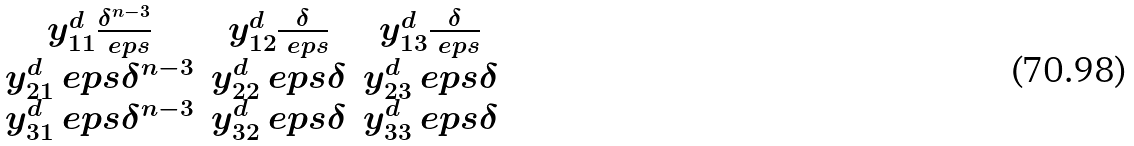Convert formula to latex. <formula><loc_0><loc_0><loc_500><loc_500>\begin{matrix} y ^ { d } _ { 1 1 } \frac { \delta ^ { n - 3 } } { \ e p s } & y ^ { d } _ { 1 2 } \frac { \delta } { \ e p s } & y ^ { d } _ { 1 3 } \frac { \delta } { \ e p s } \\ y ^ { d } _ { 2 1 } \ e p s \delta ^ { n - 3 } & y ^ { d } _ { 2 2 } \ e p s \delta & y ^ { d } _ { 2 3 } \ e p s \delta \\ y ^ { d } _ { 3 1 } \ e p s \delta ^ { n - 3 } & y ^ { d } _ { 3 2 } \ e p s \delta & y ^ { d } _ { 3 3 } \ e p s \delta \end{matrix}</formula> 